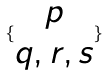Convert formula to latex. <formula><loc_0><loc_0><loc_500><loc_500>\{ \begin{matrix} p \\ q , r , s \end{matrix} \}</formula> 